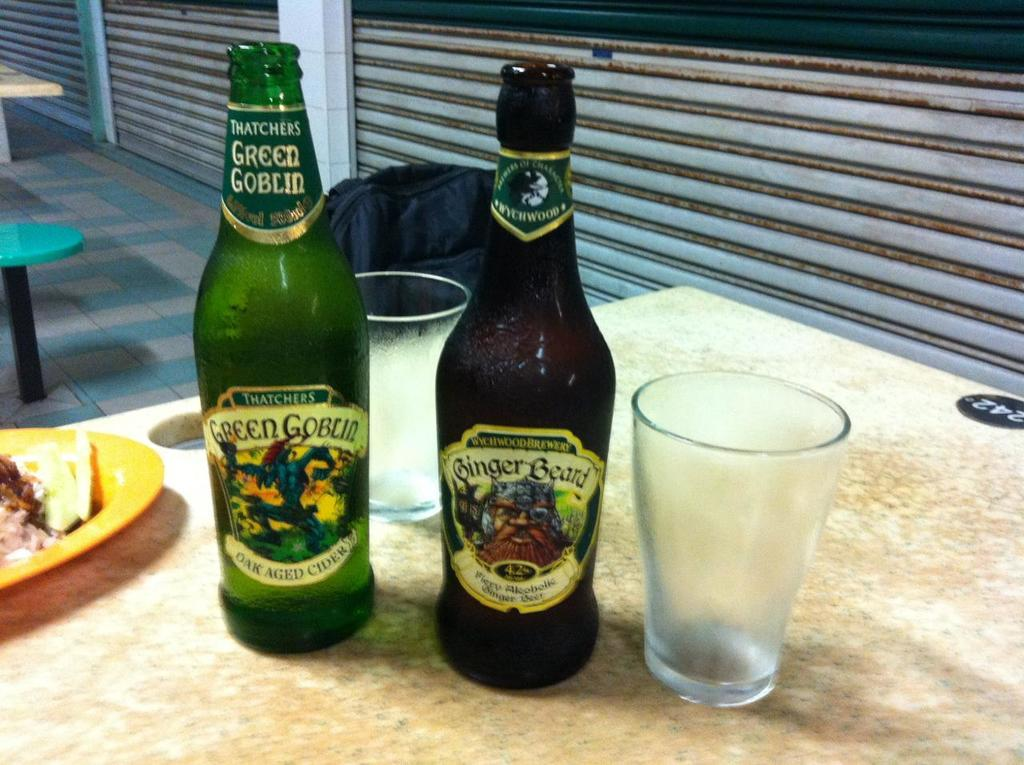<image>
Provide a brief description of the given image. Two bottles with labels of Ginger Beard sit next to an empty glass. 